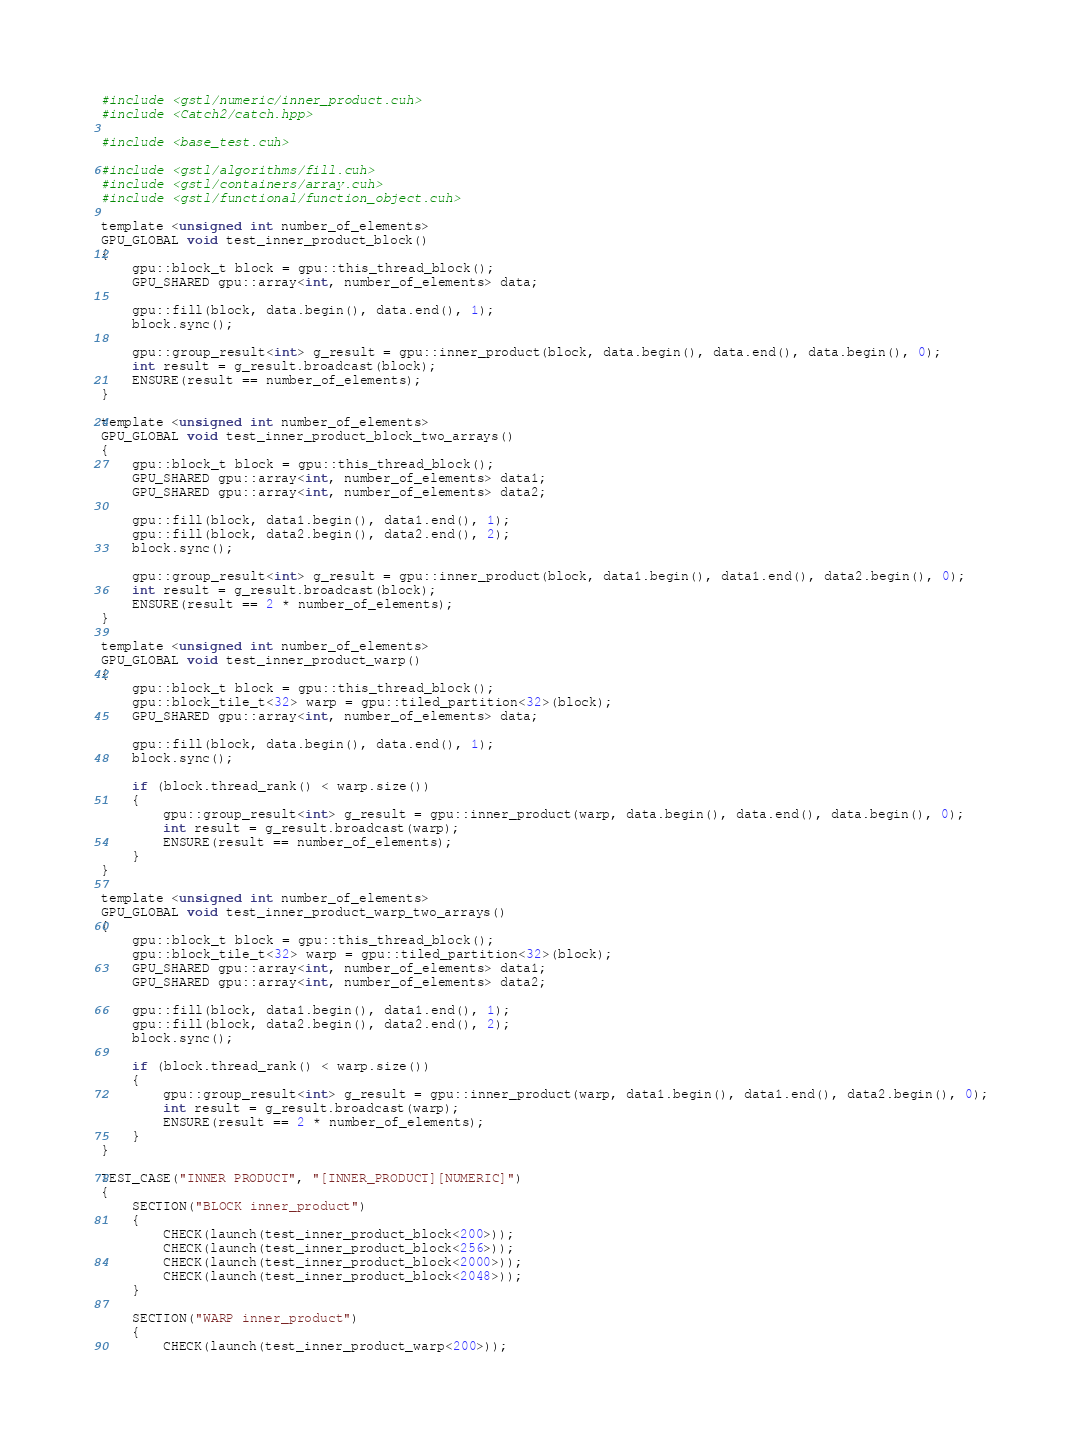Convert code to text. <code><loc_0><loc_0><loc_500><loc_500><_Cuda_>#include <gstl/numeric/inner_product.cuh>
#include <Catch2/catch.hpp>

#include <base_test.cuh>

#include <gstl/algorithms/fill.cuh>
#include <gstl/containers/array.cuh>
#include <gstl/functional/function_object.cuh>

template <unsigned int number_of_elements>
GPU_GLOBAL void test_inner_product_block()
{
	gpu::block_t block = gpu::this_thread_block();
	GPU_SHARED gpu::array<int, number_of_elements> data;

	gpu::fill(block, data.begin(), data.end(), 1);
	block.sync();

	gpu::group_result<int> g_result = gpu::inner_product(block, data.begin(), data.end(), data.begin(), 0);
	int result = g_result.broadcast(block);
	ENSURE(result == number_of_elements);
}

template <unsigned int number_of_elements>
GPU_GLOBAL void test_inner_product_block_two_arrays()
{
	gpu::block_t block = gpu::this_thread_block();
	GPU_SHARED gpu::array<int, number_of_elements> data1;
	GPU_SHARED gpu::array<int, number_of_elements> data2;

	gpu::fill(block, data1.begin(), data1.end(), 1);
	gpu::fill(block, data2.begin(), data2.end(), 2);
	block.sync();

	gpu::group_result<int> g_result = gpu::inner_product(block, data1.begin(), data1.end(), data2.begin(), 0);
	int result = g_result.broadcast(block);
	ENSURE(result == 2 * number_of_elements);
}

template <unsigned int number_of_elements>
GPU_GLOBAL void test_inner_product_warp()
{
	gpu::block_t block = gpu::this_thread_block();
	gpu::block_tile_t<32> warp = gpu::tiled_partition<32>(block);
	GPU_SHARED gpu::array<int, number_of_elements> data;

	gpu::fill(block, data.begin(), data.end(), 1);
	block.sync();

	if (block.thread_rank() < warp.size())
	{
		gpu::group_result<int> g_result = gpu::inner_product(warp, data.begin(), data.end(), data.begin(), 0);
		int result = g_result.broadcast(warp);
		ENSURE(result == number_of_elements);
	}
}

template <unsigned int number_of_elements>
GPU_GLOBAL void test_inner_product_warp_two_arrays()
{
	gpu::block_t block = gpu::this_thread_block();
	gpu::block_tile_t<32> warp = gpu::tiled_partition<32>(block);
	GPU_SHARED gpu::array<int, number_of_elements> data1;
	GPU_SHARED gpu::array<int, number_of_elements> data2;

	gpu::fill(block, data1.begin(), data1.end(), 1);
	gpu::fill(block, data2.begin(), data2.end(), 2);
	block.sync();

	if (block.thread_rank() < warp.size())
	{
		gpu::group_result<int> g_result = gpu::inner_product(warp, data1.begin(), data1.end(), data2.begin(), 0);
		int result = g_result.broadcast(warp);
		ENSURE(result == 2 * number_of_elements);
	}
}

TEST_CASE("INNER PRODUCT", "[INNER_PRODUCT][NUMERIC]")
{
	SECTION("BLOCK inner_product")
	{
		CHECK(launch(test_inner_product_block<200>));
		CHECK(launch(test_inner_product_block<256>));
		CHECK(launch(test_inner_product_block<2000>));
		CHECK(launch(test_inner_product_block<2048>));
	}

	SECTION("WARP inner_product")
	{
		CHECK(launch(test_inner_product_warp<200>));</code> 